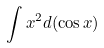<formula> <loc_0><loc_0><loc_500><loc_500>\int x ^ { 2 } d ( \cos x )</formula> 